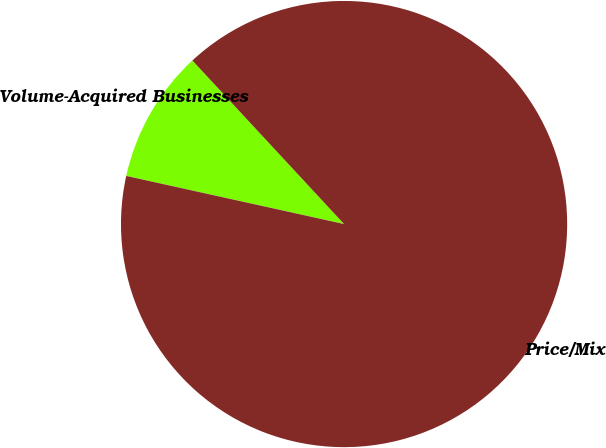Convert chart to OTSL. <chart><loc_0><loc_0><loc_500><loc_500><pie_chart><fcel>Volume-Acquired Businesses<fcel>Price/Mix<nl><fcel>9.64%<fcel>90.36%<nl></chart> 